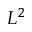Convert formula to latex. <formula><loc_0><loc_0><loc_500><loc_500>L ^ { 2 }</formula> 